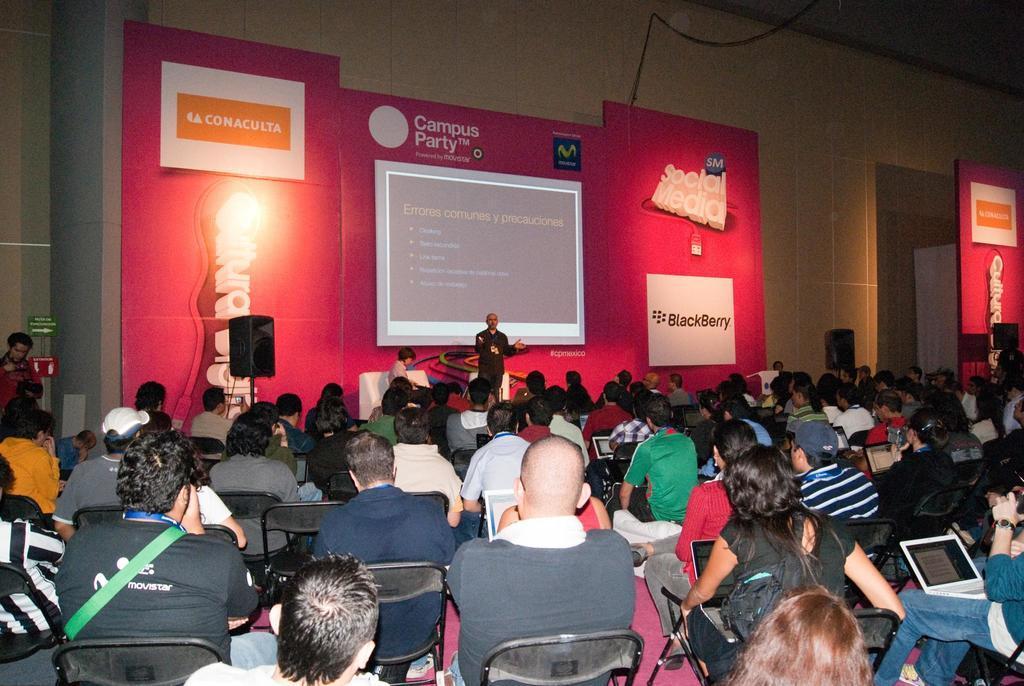Could you give a brief overview of what you see in this image? There are many people sitting on the chair. In the back a person is standing. There is a wall. On that something is written. Also there is a screen. And there are speakers with stand. 